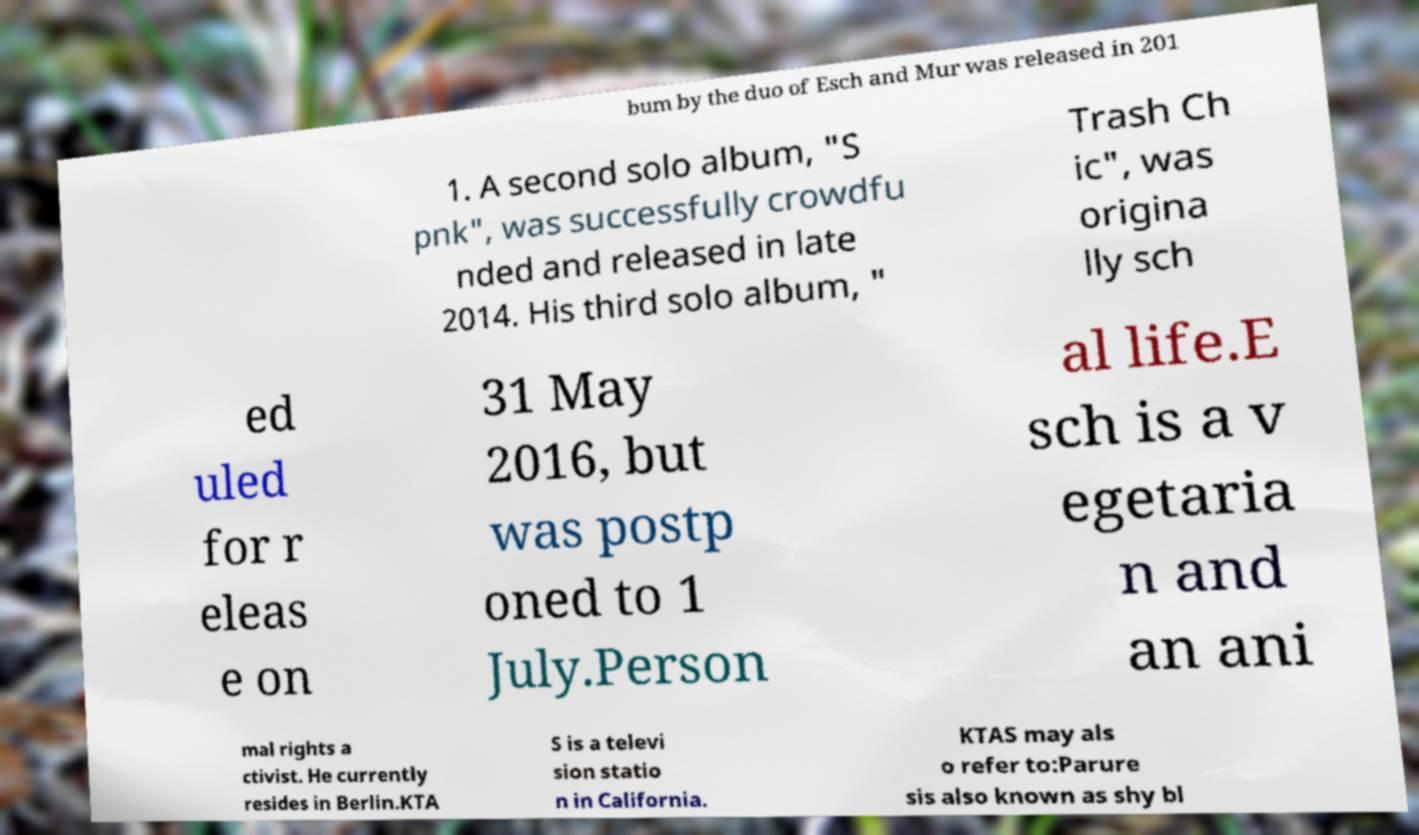I need the written content from this picture converted into text. Can you do that? bum by the duo of Esch and Mur was released in 201 1. A second solo album, "S pnk", was successfully crowdfu nded and released in late 2014. His third solo album, " Trash Ch ic", was origina lly sch ed uled for r eleas e on 31 May 2016, but was postp oned to 1 July.Person al life.E sch is a v egetaria n and an ani mal rights a ctivist. He currently resides in Berlin.KTA S is a televi sion statio n in California. KTAS may als o refer to:Parure sis also known as shy bl 